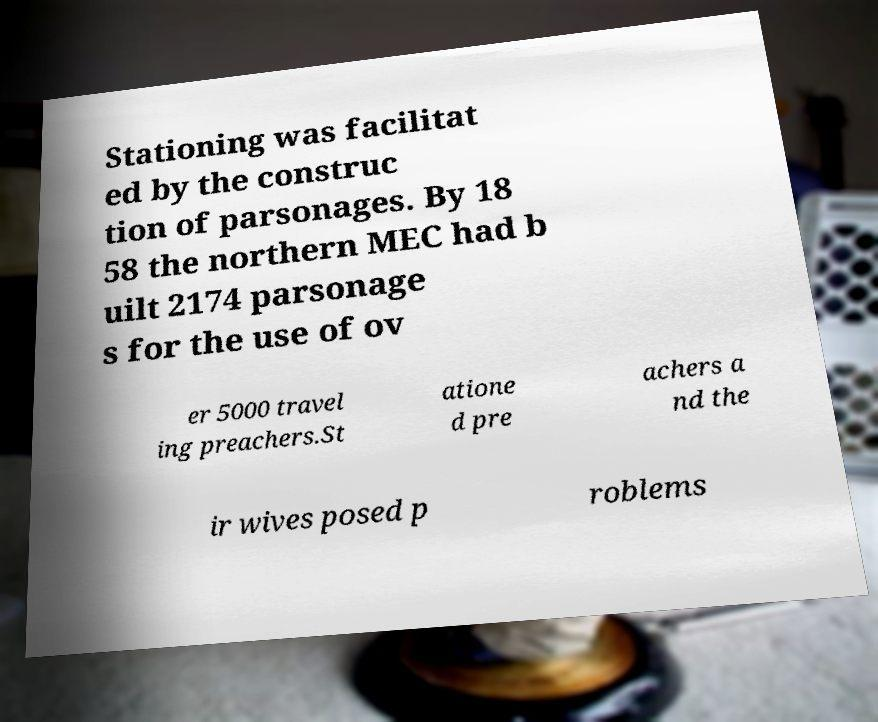Please identify and transcribe the text found in this image. Stationing was facilitat ed by the construc tion of parsonages. By 18 58 the northern MEC had b uilt 2174 parsonage s for the use of ov er 5000 travel ing preachers.St atione d pre achers a nd the ir wives posed p roblems 